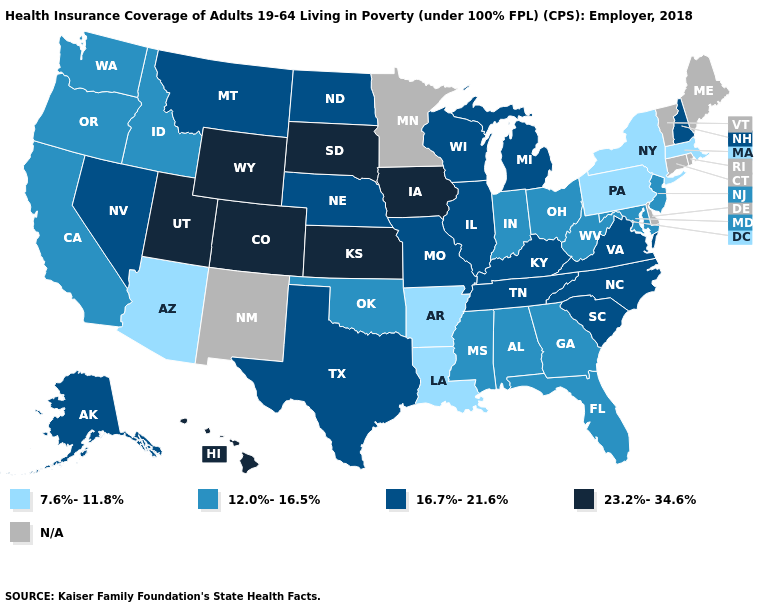What is the value of Missouri?
Answer briefly. 16.7%-21.6%. Which states have the highest value in the USA?
Concise answer only. Colorado, Hawaii, Iowa, Kansas, South Dakota, Utah, Wyoming. How many symbols are there in the legend?
Concise answer only. 5. Among the states that border New Mexico , which have the lowest value?
Concise answer only. Arizona. Which states have the highest value in the USA?
Be succinct. Colorado, Hawaii, Iowa, Kansas, South Dakota, Utah, Wyoming. Name the states that have a value in the range N/A?
Answer briefly. Connecticut, Delaware, Maine, Minnesota, New Mexico, Rhode Island, Vermont. Does Louisiana have the highest value in the South?
Keep it brief. No. Name the states that have a value in the range 12.0%-16.5%?
Keep it brief. Alabama, California, Florida, Georgia, Idaho, Indiana, Maryland, Mississippi, New Jersey, Ohio, Oklahoma, Oregon, Washington, West Virginia. What is the value of Pennsylvania?
Short answer required. 7.6%-11.8%. Among the states that border Tennessee , which have the highest value?
Be succinct. Kentucky, Missouri, North Carolina, Virginia. Does Indiana have the lowest value in the MidWest?
Give a very brief answer. Yes. Does Arkansas have the lowest value in the USA?
Write a very short answer. Yes. 